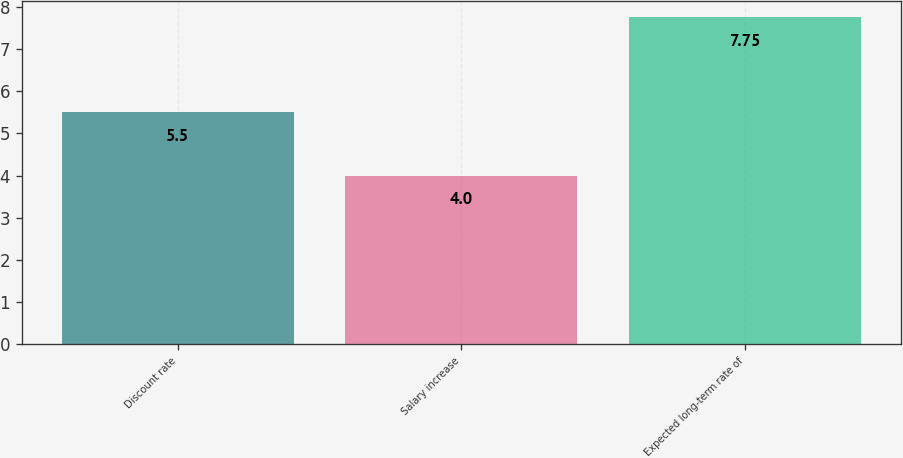Convert chart to OTSL. <chart><loc_0><loc_0><loc_500><loc_500><bar_chart><fcel>Discount rate<fcel>Salary increase<fcel>Expected long-term rate of<nl><fcel>5.5<fcel>4<fcel>7.75<nl></chart> 